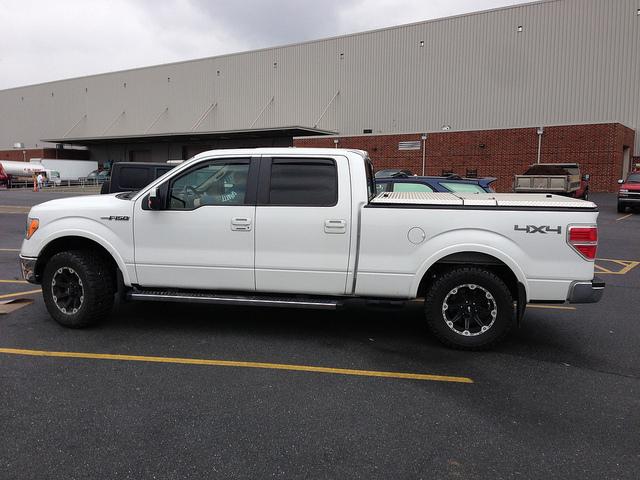What color is this vehicle?
Be succinct. White. Would this truck be a antique?
Answer briefly. No. How many tents are there?
Answer briefly. 0. What kind of tires are on the truck?
Be succinct. Black. Were these trucks assembled in the 21 century?
Give a very brief answer. Yes. What color is the pickup truck?
Give a very brief answer. White. How many doors does the car have?
Be succinct. 4. What is the number on the back of the truck?
Answer briefly. 4x4. On which side of the vehicle do you access the fuel tank?
Quick response, please. Left. Is the car situated in a parking space?
Give a very brief answer. Yes. Is the bumper chrome?
Short answer required. No. 